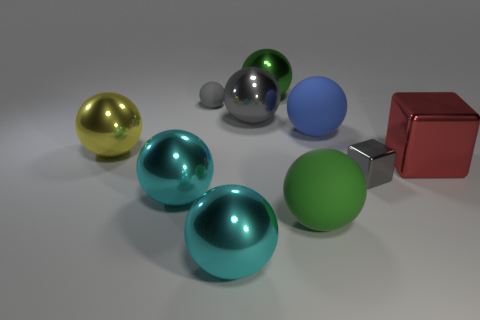Subtract 1 spheres. How many spheres are left? 7 Subtract all blue spheres. How many spheres are left? 7 Subtract all tiny spheres. How many spheres are left? 7 Subtract all red spheres. Subtract all gray blocks. How many spheres are left? 8 Subtract all balls. How many objects are left? 2 Subtract all large brown matte balls. Subtract all large gray metal balls. How many objects are left? 9 Add 6 big green objects. How many big green objects are left? 8 Add 6 big brown metallic cubes. How many big brown metallic cubes exist? 6 Subtract 0 purple balls. How many objects are left? 10 